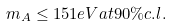<formula> <loc_0><loc_0><loc_500><loc_500>m _ { A } \leq 1 5 1 e V a t 9 0 \% c . l .</formula> 